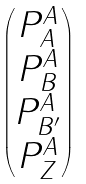Convert formula to latex. <formula><loc_0><loc_0><loc_500><loc_500>\begin{pmatrix} P ^ { A } _ { A } \\ P ^ { A } _ { B } \\ P ^ { A } _ { B ^ { \prime } } \\ P ^ { A } _ { Z } \end{pmatrix}</formula> 